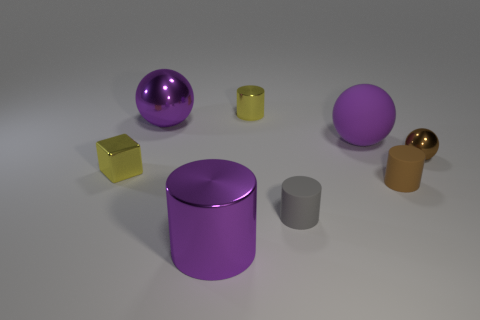Subtract all cyan cylinders. How many purple spheres are left? 2 Subtract all tiny shiny cylinders. How many cylinders are left? 3 Add 2 tiny green blocks. How many objects exist? 10 Subtract 2 cylinders. How many cylinders are left? 2 Subtract all blocks. How many objects are left? 7 Subtract all red cylinders. Subtract all purple balls. How many cylinders are left? 4 Subtract all gray cylinders. Subtract all small shiny balls. How many objects are left? 6 Add 7 large shiny spheres. How many large shiny spheres are left? 8 Add 8 brown metal blocks. How many brown metal blocks exist? 8 Subtract 0 gray blocks. How many objects are left? 8 